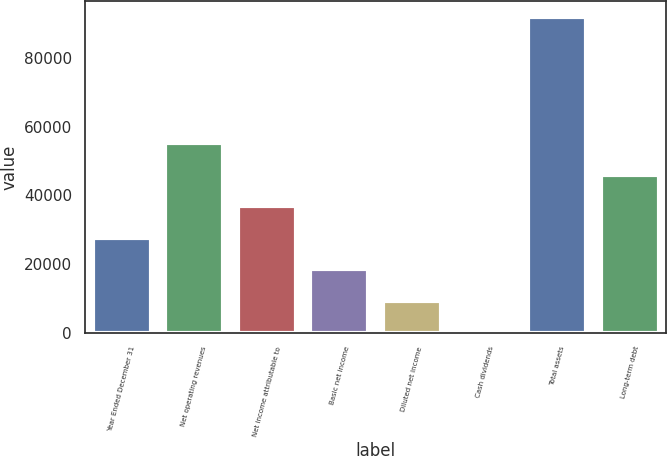Convert chart. <chart><loc_0><loc_0><loc_500><loc_500><bar_chart><fcel>Year Ended December 31<fcel>Net operating revenues<fcel>Net income attributable to<fcel>Basic net income<fcel>Diluted net income<fcel>Cash dividends<fcel>Total assets<fcel>Long-term debt<nl><fcel>27607.8<fcel>55214.3<fcel>36809.9<fcel>18405.6<fcel>9203.4<fcel>1.22<fcel>92023<fcel>46012.1<nl></chart> 